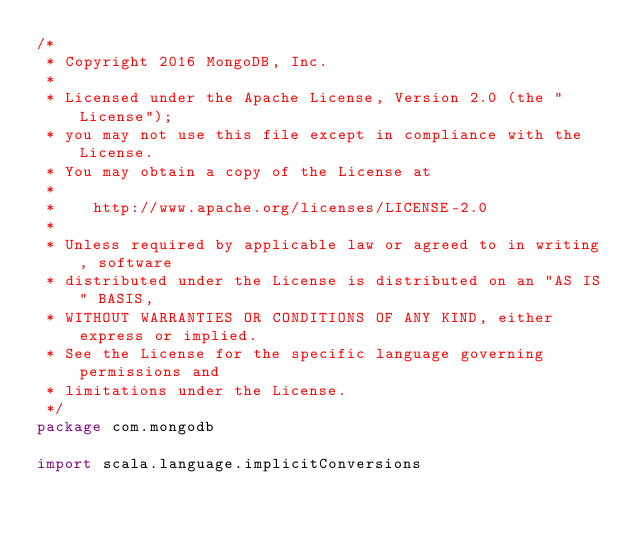<code> <loc_0><loc_0><loc_500><loc_500><_Scala_>/*
 * Copyright 2016 MongoDB, Inc.
 *
 * Licensed under the Apache License, Version 2.0 (the "License");
 * you may not use this file except in compliance with the License.
 * You may obtain a copy of the License at
 *
 *    http://www.apache.org/licenses/LICENSE-2.0
 *
 * Unless required by applicable law or agreed to in writing, software
 * distributed under the License is distributed on an "AS IS" BASIS,
 * WITHOUT WARRANTIES OR CONDITIONS OF ANY KIND, either express or implied.
 * See the License for the specific language governing permissions and
 * limitations under the License.
 */
package com.mongodb

import scala.language.implicitConversions</code> 